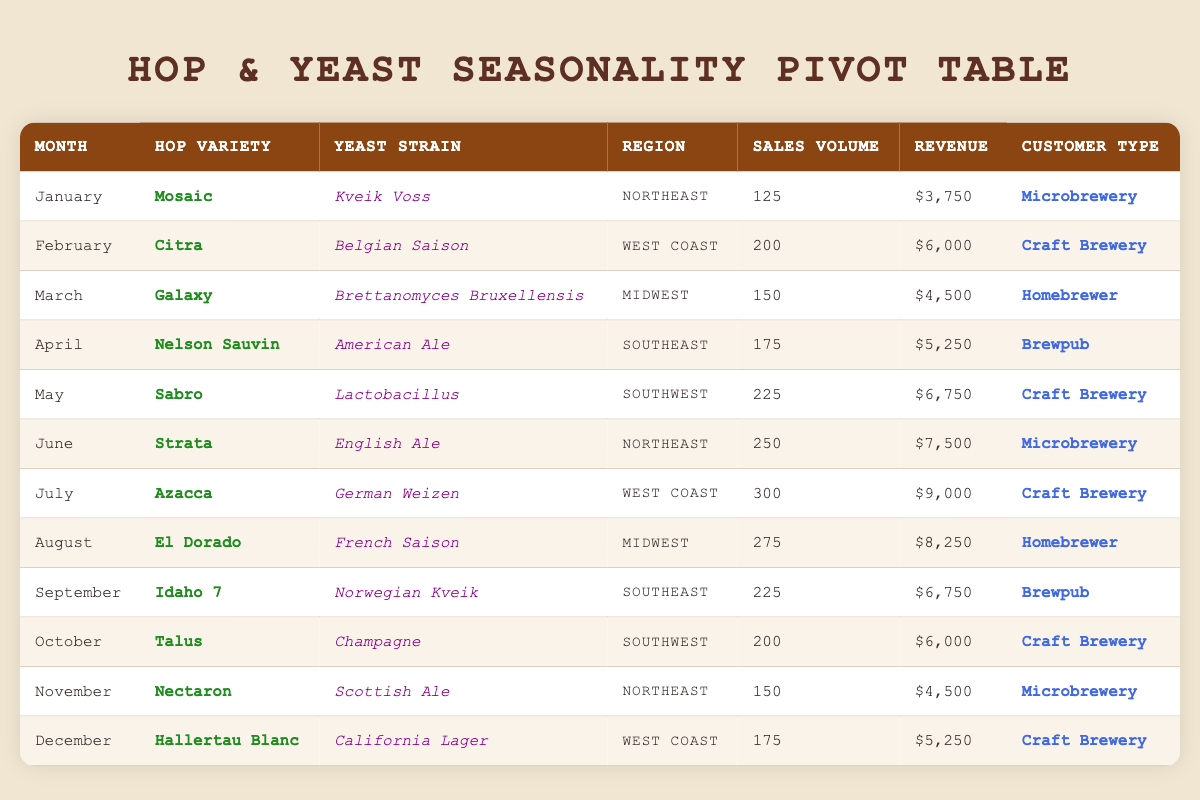What is the total sales volume for December 2023? In December 2023, the sales volume is listed as 175. There are no additional entries for that month, so 175 is the total sales volume for December.
Answer: 175 Which hop variety had the highest sales volume in June 2023? In June 2023, the hop variety listed is Strata with a sales volume of 250, which is the only entry for that month, making it the highest sales volume for June.
Answer: Strata What is the average revenue for the Craft Brewery customer type? To find the average revenue for Craft Breweries, we first need to identify their revenues: $6,000 (February), $6,750 (May), $9,000 (July), $6,000 (October), and $5,250 (December). Adding these amounts gives $6,000 + $6,750 + $9,000 + $6,000 + $5,250 = $33,000. Now, dividing by the number of entries (5 entries), we get $33,000 / 5 = $6,600 as the average revenue for Craft Breweries.
Answer: 6600 Is there a sales volume of over 300 for any hop variety in the year 2023? Looking through the sales volume data for 2023, the maximum sales volume recorded is 300, which occurs in July with the hop variety Azacca. Since no entries exceed 300, the answer is no.
Answer: No Which region had the lowest sales volume and what was that value? To find the region with the lowest sales volume, we can compare all entries. The sales volumes are: 125 (Northeast), 200 (West Coast), 150 (Midwest), 175 (Southeast), 225 (Southwest), 250 (Northeast), 300 (West Coast), 275 (Midwest), 225 (Southeast), 200 (Southwest), 150 (Northeast), and 175 (West Coast). The lowest value is 125 for the Northeast.
Answer: Northeast, 125 How much revenue was generated in the month of September 2023? Referring to the data for September 2023, the revenue listed is $6,750. There are no other entries affecting this month's revenue total.
Answer: 6750 